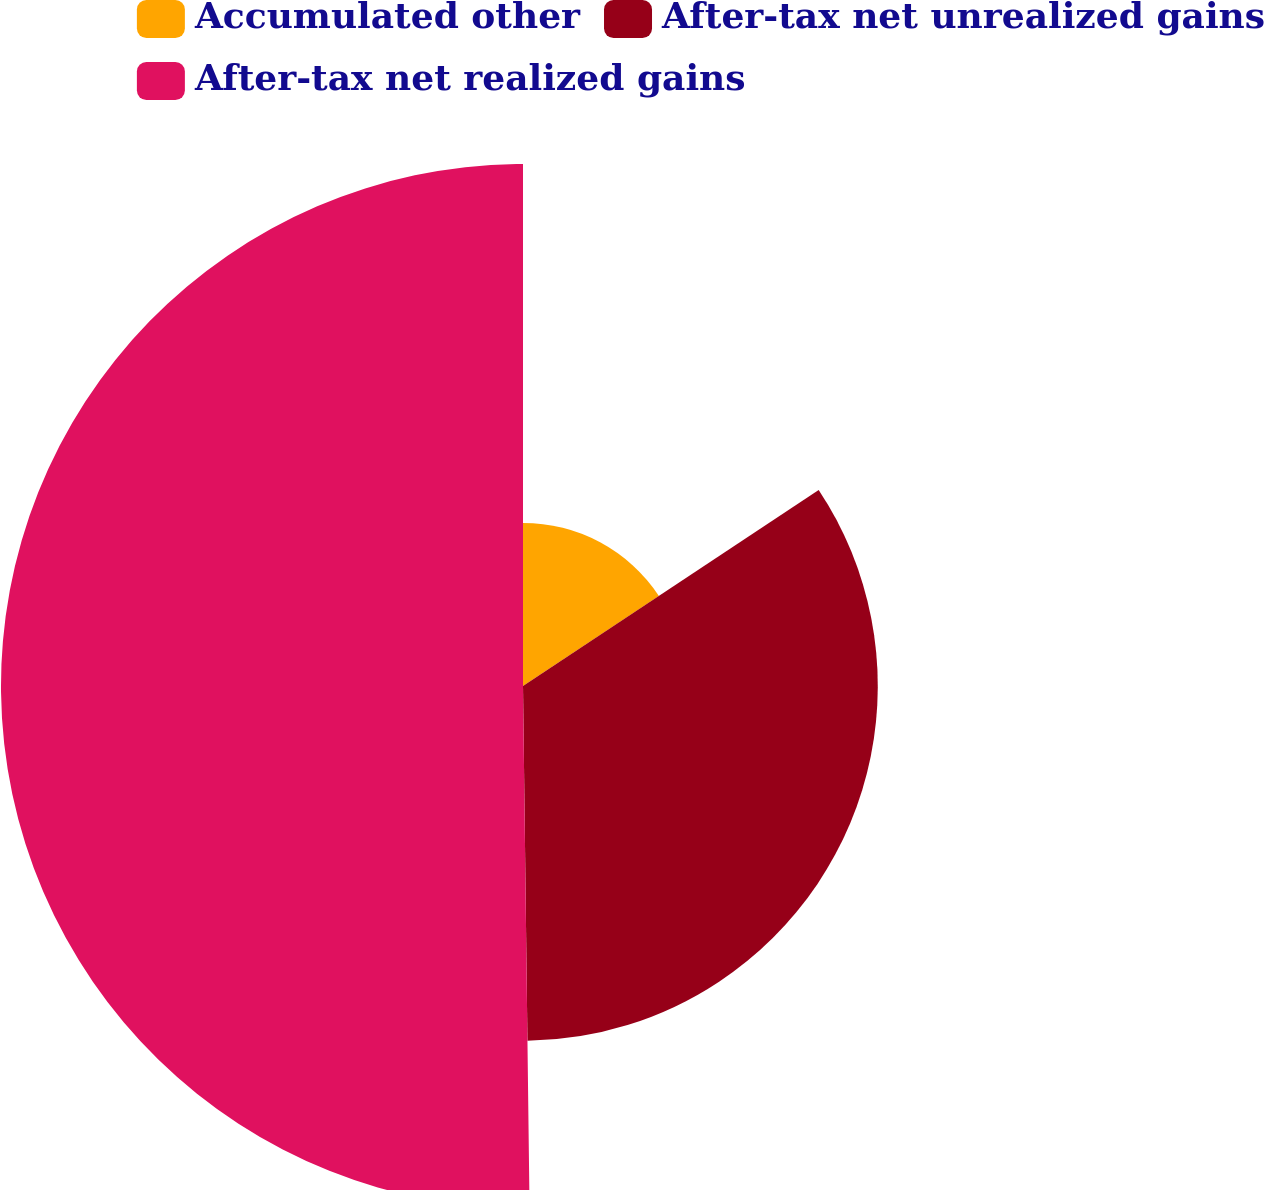Convert chart. <chart><loc_0><loc_0><loc_500><loc_500><pie_chart><fcel>Accumulated other<fcel>After-tax net unrealized gains<fcel>After-tax net realized gains<nl><fcel>15.68%<fcel>34.12%<fcel>50.2%<nl></chart> 